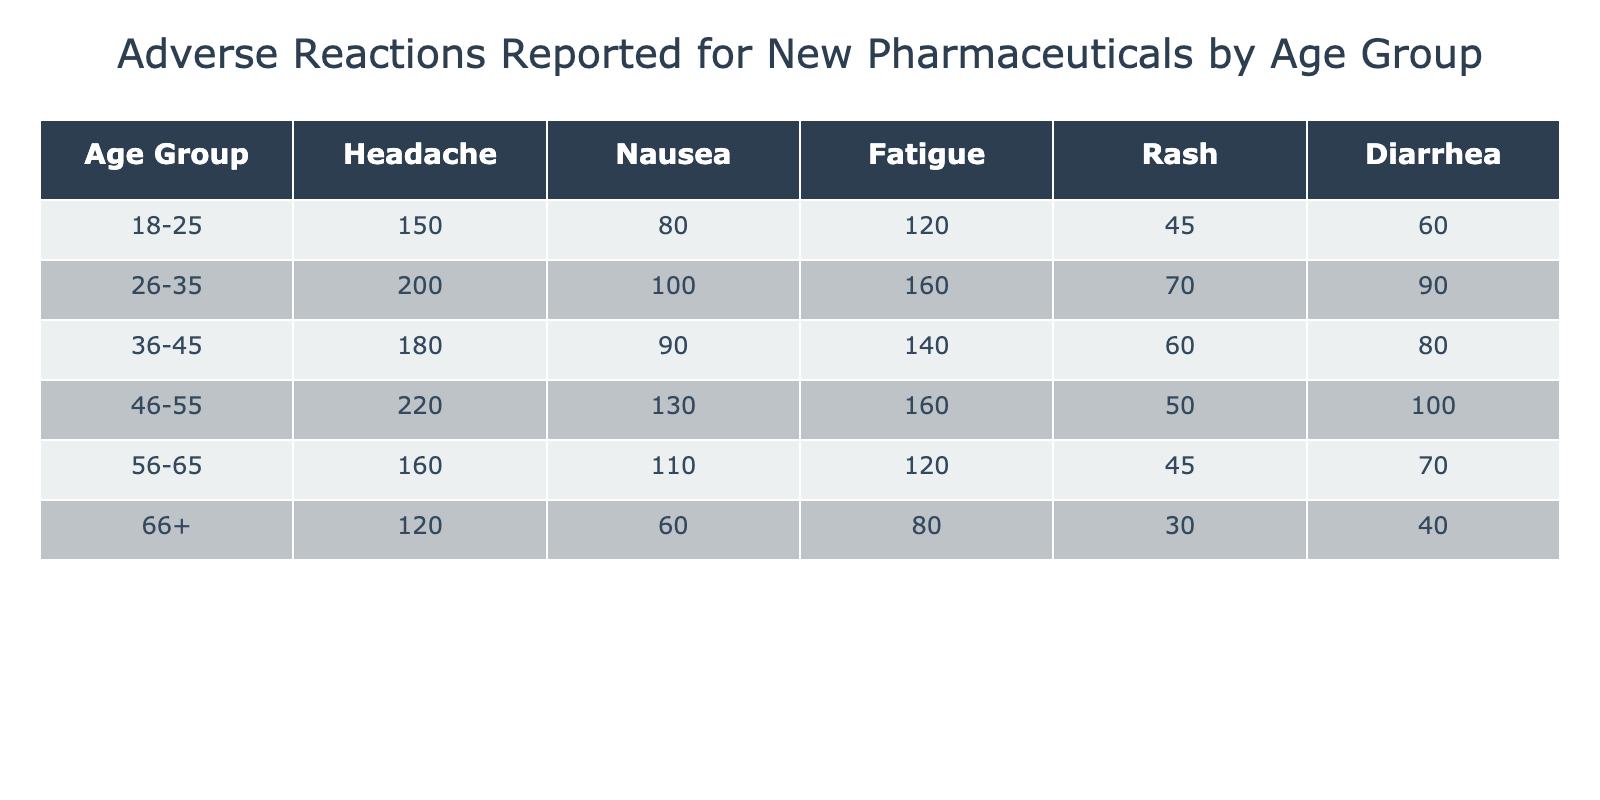What is the highest reported amount of headache among all age groups? Looking at the headache column in the table, the highest value is in the 46-55 age group with 220 reported headaches.
Answer: 220 Which age group reported the least cases of diarrhea? In the diarrhea column, the age group 66 + has the lowest value, which is 40 reported cases.
Answer: 40 What is the total number of fatigue cases reported for all age groups combined? To find the total fatigue cases, we add the values for each age group: 120 + 160 + 140 + 160 + 120 + 80 = 780.
Answer: 780 Is there a higher number of nausea cases in the 26-35 age group compared to the 36-45 age group? The 26-35 age group reported 100 nausea cases, while the 36-45 age group reported 90. Thus, it is true that the 26-35 age group has a higher number of nausea cases.
Answer: Yes What is the average number of rash cases reported across all age groups? We first sum the reported rash cases: 45 + 70 + 60 + 50 + 45 + 30 = 300. Then, we divide by the number of age groups, which is 6. Hence, the average is 300/6 = 50.
Answer: 50 Which age group reported the highest incidence of both headache and fatigue combined? We calculate the total for each age group by adding headache and fatigue cases: for 18-25: 150 + 120 = 270; for 26-35: 200 + 160 = 360; for 36-45: 180 + 140 = 320; for 46-55: 220 + 160 = 380; for 56-65: 160 + 120 = 280; for 66+: 120 + 80 = 200. The highest is in the 46-55 age group with a total of 380.
Answer: 46-55 Do older age groups (56 and up) generally report lower numbers of adverse reactions compared to younger age groups (18-35)? When comparing the two groups, we find: for 18-25 the sum is (150+80+120+45+60) = 455 and for 26-35 it is (200+100+160+70+90) = 620. For 56-65: (160+110+120+45+70) = 505 and for 66+: (120+60+80+30+40) = 330. The older groups combined show 505 + 330 = 835, while the younger groups combined show 455 + 620 = 1075. Therefore, the older groups report lower numbers of adverse reactions.
Answer: Yes 